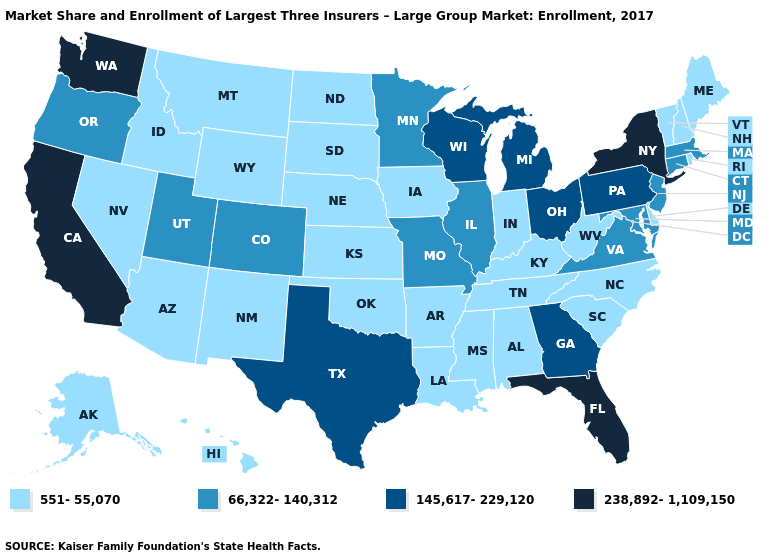Does the map have missing data?
Give a very brief answer. No. What is the value of Florida?
Write a very short answer. 238,892-1,109,150. What is the value of Florida?
Quick response, please. 238,892-1,109,150. Does the map have missing data?
Answer briefly. No. Does Utah have the lowest value in the USA?
Write a very short answer. No. How many symbols are there in the legend?
Give a very brief answer. 4. What is the lowest value in states that border North Dakota?
Quick response, please. 551-55,070. What is the highest value in states that border Idaho?
Write a very short answer. 238,892-1,109,150. Does the map have missing data?
Concise answer only. No. Does Illinois have the same value as Utah?
Give a very brief answer. Yes. What is the value of New Hampshire?
Be succinct. 551-55,070. Does the first symbol in the legend represent the smallest category?
Answer briefly. Yes. Among the states that border Delaware , which have the highest value?
Keep it brief. Pennsylvania. How many symbols are there in the legend?
Answer briefly. 4. What is the lowest value in the Northeast?
Write a very short answer. 551-55,070. 